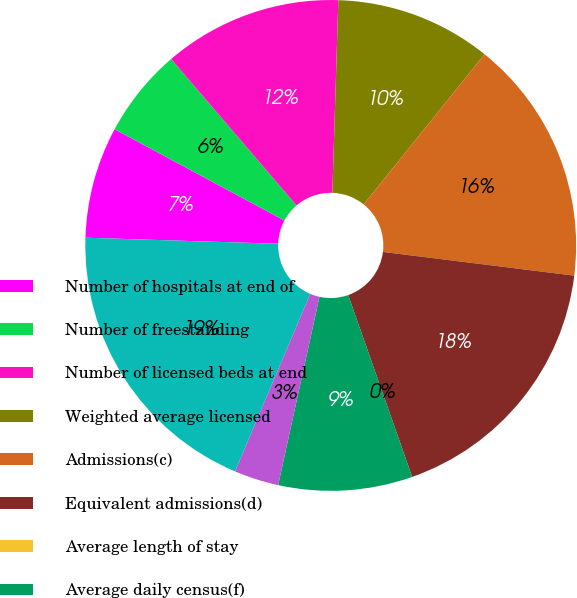Convert chart to OTSL. <chart><loc_0><loc_0><loc_500><loc_500><pie_chart><fcel>Number of hospitals at end of<fcel>Number of freestanding<fcel>Number of licensed beds at end<fcel>Weighted average licensed<fcel>Admissions(c)<fcel>Equivalent admissions(d)<fcel>Average length of stay<fcel>Average daily census(f)<fcel>Occupancy(g)<fcel>Emergency room visits(h)<nl><fcel>7.35%<fcel>5.88%<fcel>11.76%<fcel>10.29%<fcel>16.18%<fcel>17.65%<fcel>0.0%<fcel>8.82%<fcel>2.94%<fcel>19.12%<nl></chart> 